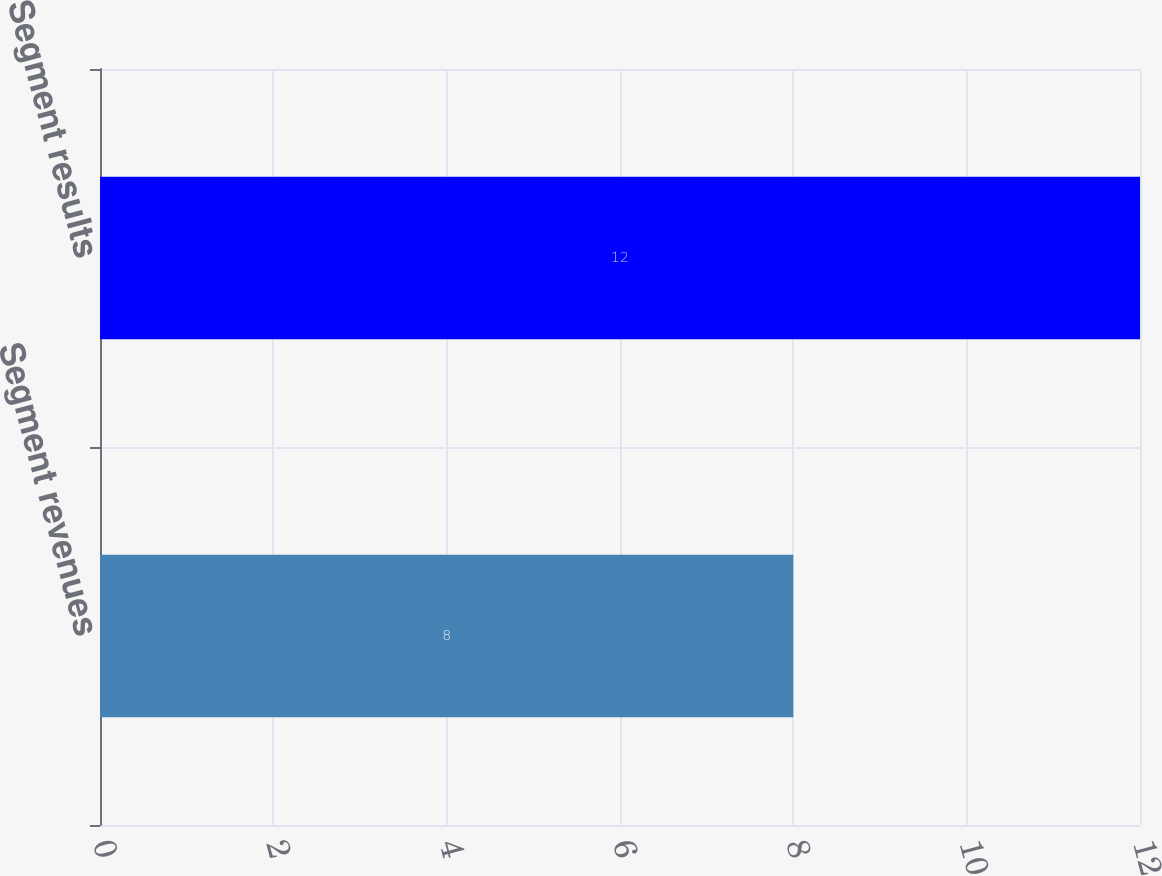Convert chart. <chart><loc_0><loc_0><loc_500><loc_500><bar_chart><fcel>Segment revenues<fcel>Segment results<nl><fcel>8<fcel>12<nl></chart> 